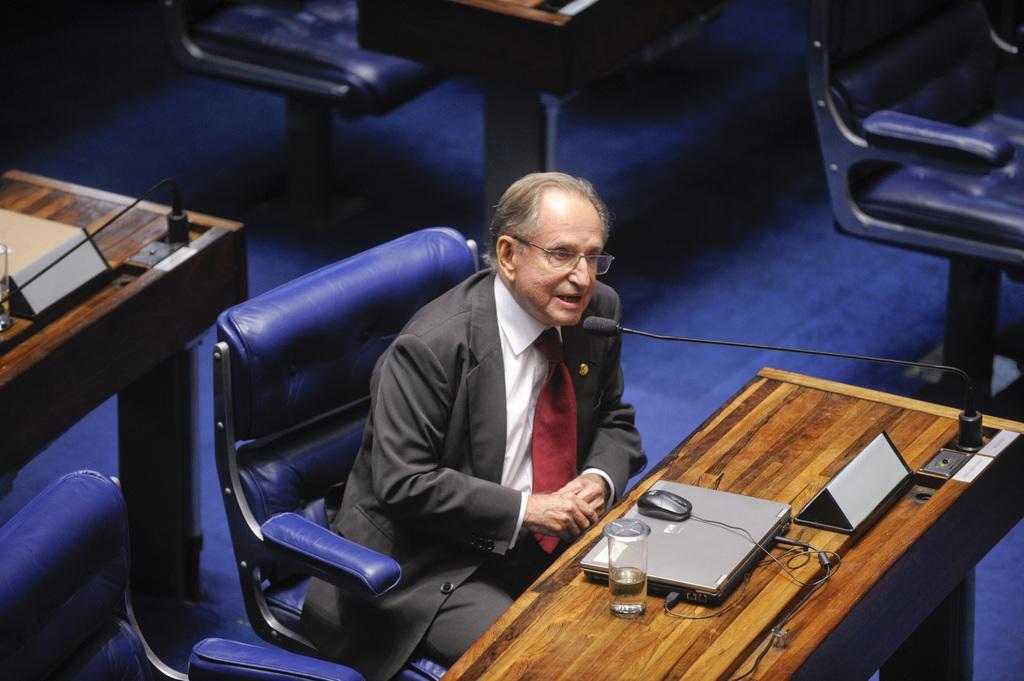Can you describe this image briefly? This picture we can see a person sitting on the chair in front of him there is a table on the table we can see the laptop Mouse glass of water and they are so many chairs and table around. 